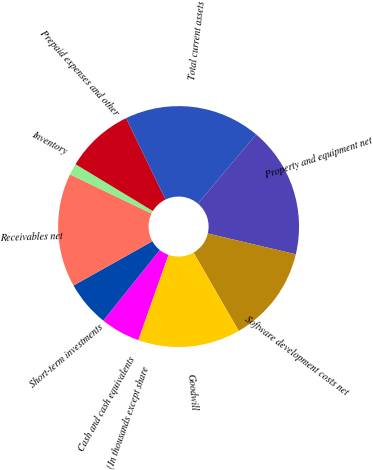Convert chart to OTSL. <chart><loc_0><loc_0><loc_500><loc_500><pie_chart><fcel>(In thousands except share<fcel>Cash and cash equivalents<fcel>Short-term investments<fcel>Receivables net<fcel>Inventory<fcel>Prepaid expenses and other<fcel>Total current assets<fcel>Property and equipment net<fcel>Software development costs net<fcel>Goodwill<nl><fcel>0.0%<fcel>5.34%<fcel>6.11%<fcel>15.27%<fcel>1.53%<fcel>9.16%<fcel>18.32%<fcel>17.56%<fcel>12.98%<fcel>13.74%<nl></chart> 